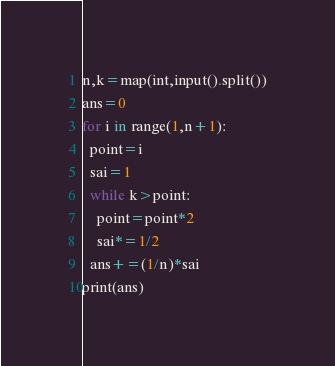<code> <loc_0><loc_0><loc_500><loc_500><_Python_>n,k=map(int,input().split())
ans=0
for i in range(1,n+1):
  point=i
  sai=1
  while k>point:
    point=point*2
    sai*=1/2
  ans+=(1/n)*sai
print(ans)</code> 